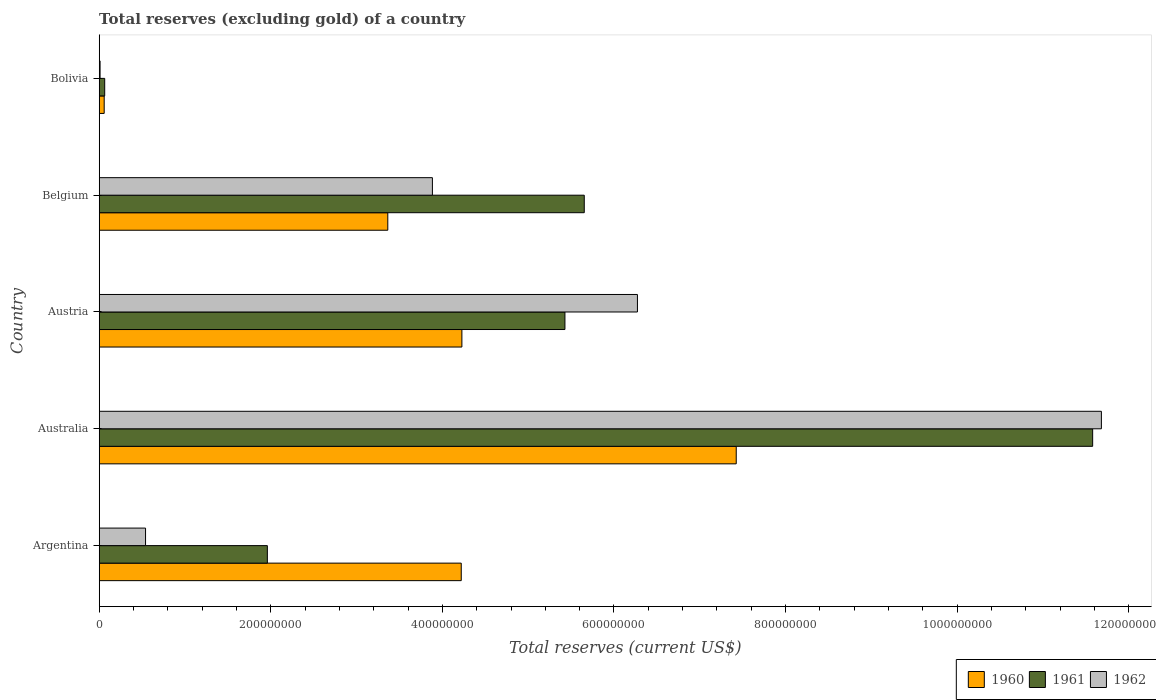How many different coloured bars are there?
Your answer should be very brief. 3. Are the number of bars per tick equal to the number of legend labels?
Make the answer very short. Yes. Are the number of bars on each tick of the Y-axis equal?
Provide a short and direct response. Yes. How many bars are there on the 1st tick from the bottom?
Give a very brief answer. 3. In how many cases, is the number of bars for a given country not equal to the number of legend labels?
Offer a very short reply. 0. What is the total reserves (excluding gold) in 1962 in Belgium?
Ensure brevity in your answer.  3.88e+08. Across all countries, what is the maximum total reserves (excluding gold) in 1961?
Keep it short and to the point. 1.16e+09. Across all countries, what is the minimum total reserves (excluding gold) in 1960?
Give a very brief answer. 5.80e+06. What is the total total reserves (excluding gold) in 1960 in the graph?
Offer a very short reply. 1.93e+09. What is the difference between the total reserves (excluding gold) in 1961 in Australia and that in Bolivia?
Provide a succinct answer. 1.15e+09. What is the difference between the total reserves (excluding gold) in 1962 in Bolivia and the total reserves (excluding gold) in 1960 in Australia?
Your answer should be very brief. -7.42e+08. What is the average total reserves (excluding gold) in 1962 per country?
Make the answer very short. 4.48e+08. What is the difference between the total reserves (excluding gold) in 1962 and total reserves (excluding gold) in 1960 in Argentina?
Provide a short and direct response. -3.68e+08. In how many countries, is the total reserves (excluding gold) in 1960 greater than 880000000 US$?
Provide a succinct answer. 0. What is the ratio of the total reserves (excluding gold) in 1961 in Australia to that in Austria?
Your answer should be very brief. 2.13. What is the difference between the highest and the second highest total reserves (excluding gold) in 1960?
Make the answer very short. 3.20e+08. What is the difference between the highest and the lowest total reserves (excluding gold) in 1960?
Offer a very short reply. 7.37e+08. Is the sum of the total reserves (excluding gold) in 1962 in Australia and Austria greater than the maximum total reserves (excluding gold) in 1960 across all countries?
Offer a terse response. Yes. What does the 1st bar from the bottom in Belgium represents?
Offer a terse response. 1960. Are all the bars in the graph horizontal?
Your response must be concise. Yes. Does the graph contain grids?
Your answer should be compact. No. How many legend labels are there?
Your answer should be compact. 3. What is the title of the graph?
Your answer should be compact. Total reserves (excluding gold) of a country. What is the label or title of the X-axis?
Provide a short and direct response. Total reserves (current US$). What is the Total reserves (current US$) in 1960 in Argentina?
Make the answer very short. 4.22e+08. What is the Total reserves (current US$) in 1961 in Argentina?
Offer a terse response. 1.96e+08. What is the Total reserves (current US$) of 1962 in Argentina?
Provide a succinct answer. 5.40e+07. What is the Total reserves (current US$) in 1960 in Australia?
Provide a short and direct response. 7.43e+08. What is the Total reserves (current US$) of 1961 in Australia?
Your answer should be compact. 1.16e+09. What is the Total reserves (current US$) in 1962 in Australia?
Your answer should be compact. 1.17e+09. What is the Total reserves (current US$) in 1960 in Austria?
Provide a succinct answer. 4.23e+08. What is the Total reserves (current US$) of 1961 in Austria?
Ensure brevity in your answer.  5.43e+08. What is the Total reserves (current US$) of 1962 in Austria?
Your answer should be compact. 6.27e+08. What is the Total reserves (current US$) of 1960 in Belgium?
Offer a very short reply. 3.36e+08. What is the Total reserves (current US$) in 1961 in Belgium?
Provide a short and direct response. 5.65e+08. What is the Total reserves (current US$) in 1962 in Belgium?
Keep it short and to the point. 3.88e+08. What is the Total reserves (current US$) in 1960 in Bolivia?
Provide a short and direct response. 5.80e+06. What is the Total reserves (current US$) of 1961 in Bolivia?
Provide a short and direct response. 6.40e+06. What is the Total reserves (current US$) of 1962 in Bolivia?
Your response must be concise. 1.00e+06. Across all countries, what is the maximum Total reserves (current US$) of 1960?
Your answer should be very brief. 7.43e+08. Across all countries, what is the maximum Total reserves (current US$) of 1961?
Offer a very short reply. 1.16e+09. Across all countries, what is the maximum Total reserves (current US$) of 1962?
Provide a succinct answer. 1.17e+09. Across all countries, what is the minimum Total reserves (current US$) of 1960?
Provide a succinct answer. 5.80e+06. Across all countries, what is the minimum Total reserves (current US$) of 1961?
Make the answer very short. 6.40e+06. What is the total Total reserves (current US$) in 1960 in the graph?
Ensure brevity in your answer.  1.93e+09. What is the total Total reserves (current US$) in 1961 in the graph?
Provide a succinct answer. 2.47e+09. What is the total Total reserves (current US$) of 1962 in the graph?
Ensure brevity in your answer.  2.24e+09. What is the difference between the Total reserves (current US$) in 1960 in Argentina and that in Australia?
Keep it short and to the point. -3.21e+08. What is the difference between the Total reserves (current US$) in 1961 in Argentina and that in Australia?
Ensure brevity in your answer.  -9.62e+08. What is the difference between the Total reserves (current US$) in 1962 in Argentina and that in Australia?
Your response must be concise. -1.11e+09. What is the difference between the Total reserves (current US$) in 1960 in Argentina and that in Austria?
Give a very brief answer. -7.60e+05. What is the difference between the Total reserves (current US$) in 1961 in Argentina and that in Austria?
Your answer should be compact. -3.47e+08. What is the difference between the Total reserves (current US$) of 1962 in Argentina and that in Austria?
Offer a terse response. -5.73e+08. What is the difference between the Total reserves (current US$) of 1960 in Argentina and that in Belgium?
Your answer should be compact. 8.56e+07. What is the difference between the Total reserves (current US$) of 1961 in Argentina and that in Belgium?
Make the answer very short. -3.69e+08. What is the difference between the Total reserves (current US$) of 1962 in Argentina and that in Belgium?
Your answer should be compact. -3.34e+08. What is the difference between the Total reserves (current US$) in 1960 in Argentina and that in Bolivia?
Make the answer very short. 4.16e+08. What is the difference between the Total reserves (current US$) in 1961 in Argentina and that in Bolivia?
Your response must be concise. 1.90e+08. What is the difference between the Total reserves (current US$) in 1962 in Argentina and that in Bolivia?
Make the answer very short. 5.30e+07. What is the difference between the Total reserves (current US$) in 1960 in Australia and that in Austria?
Provide a short and direct response. 3.20e+08. What is the difference between the Total reserves (current US$) in 1961 in Australia and that in Austria?
Provide a short and direct response. 6.15e+08. What is the difference between the Total reserves (current US$) of 1962 in Australia and that in Austria?
Keep it short and to the point. 5.41e+08. What is the difference between the Total reserves (current US$) of 1960 in Australia and that in Belgium?
Offer a terse response. 4.06e+08. What is the difference between the Total reserves (current US$) of 1961 in Australia and that in Belgium?
Ensure brevity in your answer.  5.93e+08. What is the difference between the Total reserves (current US$) of 1962 in Australia and that in Belgium?
Ensure brevity in your answer.  7.80e+08. What is the difference between the Total reserves (current US$) of 1960 in Australia and that in Bolivia?
Your response must be concise. 7.37e+08. What is the difference between the Total reserves (current US$) in 1961 in Australia and that in Bolivia?
Give a very brief answer. 1.15e+09. What is the difference between the Total reserves (current US$) of 1962 in Australia and that in Bolivia?
Ensure brevity in your answer.  1.17e+09. What is the difference between the Total reserves (current US$) of 1960 in Austria and that in Belgium?
Your answer should be very brief. 8.64e+07. What is the difference between the Total reserves (current US$) in 1961 in Austria and that in Belgium?
Your response must be concise. -2.25e+07. What is the difference between the Total reserves (current US$) in 1962 in Austria and that in Belgium?
Offer a terse response. 2.39e+08. What is the difference between the Total reserves (current US$) of 1960 in Austria and that in Bolivia?
Provide a short and direct response. 4.17e+08. What is the difference between the Total reserves (current US$) of 1961 in Austria and that in Bolivia?
Your response must be concise. 5.36e+08. What is the difference between the Total reserves (current US$) in 1962 in Austria and that in Bolivia?
Provide a succinct answer. 6.26e+08. What is the difference between the Total reserves (current US$) in 1960 in Belgium and that in Bolivia?
Offer a terse response. 3.31e+08. What is the difference between the Total reserves (current US$) of 1961 in Belgium and that in Bolivia?
Your answer should be very brief. 5.59e+08. What is the difference between the Total reserves (current US$) of 1962 in Belgium and that in Bolivia?
Provide a succinct answer. 3.87e+08. What is the difference between the Total reserves (current US$) of 1960 in Argentina and the Total reserves (current US$) of 1961 in Australia?
Offer a very short reply. -7.36e+08. What is the difference between the Total reserves (current US$) of 1960 in Argentina and the Total reserves (current US$) of 1962 in Australia?
Your answer should be very brief. -7.46e+08. What is the difference between the Total reserves (current US$) in 1961 in Argentina and the Total reserves (current US$) in 1962 in Australia?
Your answer should be very brief. -9.72e+08. What is the difference between the Total reserves (current US$) in 1960 in Argentina and the Total reserves (current US$) in 1961 in Austria?
Ensure brevity in your answer.  -1.21e+08. What is the difference between the Total reserves (current US$) of 1960 in Argentina and the Total reserves (current US$) of 1962 in Austria?
Offer a terse response. -2.05e+08. What is the difference between the Total reserves (current US$) in 1961 in Argentina and the Total reserves (current US$) in 1962 in Austria?
Give a very brief answer. -4.31e+08. What is the difference between the Total reserves (current US$) in 1960 in Argentina and the Total reserves (current US$) in 1961 in Belgium?
Make the answer very short. -1.43e+08. What is the difference between the Total reserves (current US$) of 1960 in Argentina and the Total reserves (current US$) of 1962 in Belgium?
Give a very brief answer. 3.36e+07. What is the difference between the Total reserves (current US$) of 1961 in Argentina and the Total reserves (current US$) of 1962 in Belgium?
Your answer should be very brief. -1.92e+08. What is the difference between the Total reserves (current US$) of 1960 in Argentina and the Total reserves (current US$) of 1961 in Bolivia?
Your response must be concise. 4.16e+08. What is the difference between the Total reserves (current US$) in 1960 in Argentina and the Total reserves (current US$) in 1962 in Bolivia?
Offer a terse response. 4.21e+08. What is the difference between the Total reserves (current US$) in 1961 in Argentina and the Total reserves (current US$) in 1962 in Bolivia?
Your response must be concise. 1.95e+08. What is the difference between the Total reserves (current US$) in 1960 in Australia and the Total reserves (current US$) in 1961 in Austria?
Give a very brief answer. 2.00e+08. What is the difference between the Total reserves (current US$) in 1960 in Australia and the Total reserves (current US$) in 1962 in Austria?
Your response must be concise. 1.15e+08. What is the difference between the Total reserves (current US$) of 1961 in Australia and the Total reserves (current US$) of 1962 in Austria?
Offer a terse response. 5.31e+08. What is the difference between the Total reserves (current US$) in 1960 in Australia and the Total reserves (current US$) in 1961 in Belgium?
Keep it short and to the point. 1.77e+08. What is the difference between the Total reserves (current US$) of 1960 in Australia and the Total reserves (current US$) of 1962 in Belgium?
Your response must be concise. 3.54e+08. What is the difference between the Total reserves (current US$) in 1961 in Australia and the Total reserves (current US$) in 1962 in Belgium?
Ensure brevity in your answer.  7.70e+08. What is the difference between the Total reserves (current US$) of 1960 in Australia and the Total reserves (current US$) of 1961 in Bolivia?
Your answer should be compact. 7.36e+08. What is the difference between the Total reserves (current US$) of 1960 in Australia and the Total reserves (current US$) of 1962 in Bolivia?
Give a very brief answer. 7.42e+08. What is the difference between the Total reserves (current US$) in 1961 in Australia and the Total reserves (current US$) in 1962 in Bolivia?
Make the answer very short. 1.16e+09. What is the difference between the Total reserves (current US$) of 1960 in Austria and the Total reserves (current US$) of 1961 in Belgium?
Offer a very short reply. -1.43e+08. What is the difference between the Total reserves (current US$) in 1960 in Austria and the Total reserves (current US$) in 1962 in Belgium?
Offer a terse response. 3.44e+07. What is the difference between the Total reserves (current US$) of 1961 in Austria and the Total reserves (current US$) of 1962 in Belgium?
Give a very brief answer. 1.54e+08. What is the difference between the Total reserves (current US$) in 1960 in Austria and the Total reserves (current US$) in 1961 in Bolivia?
Your response must be concise. 4.16e+08. What is the difference between the Total reserves (current US$) in 1960 in Austria and the Total reserves (current US$) in 1962 in Bolivia?
Keep it short and to the point. 4.22e+08. What is the difference between the Total reserves (current US$) in 1961 in Austria and the Total reserves (current US$) in 1962 in Bolivia?
Make the answer very short. 5.42e+08. What is the difference between the Total reserves (current US$) of 1960 in Belgium and the Total reserves (current US$) of 1961 in Bolivia?
Your answer should be very brief. 3.30e+08. What is the difference between the Total reserves (current US$) of 1960 in Belgium and the Total reserves (current US$) of 1962 in Bolivia?
Offer a very short reply. 3.35e+08. What is the difference between the Total reserves (current US$) of 1961 in Belgium and the Total reserves (current US$) of 1962 in Bolivia?
Provide a short and direct response. 5.64e+08. What is the average Total reserves (current US$) in 1960 per country?
Make the answer very short. 3.86e+08. What is the average Total reserves (current US$) of 1961 per country?
Ensure brevity in your answer.  4.94e+08. What is the average Total reserves (current US$) of 1962 per country?
Offer a very short reply. 4.48e+08. What is the difference between the Total reserves (current US$) in 1960 and Total reserves (current US$) in 1961 in Argentina?
Ensure brevity in your answer.  2.26e+08. What is the difference between the Total reserves (current US$) of 1960 and Total reserves (current US$) of 1962 in Argentina?
Your response must be concise. 3.68e+08. What is the difference between the Total reserves (current US$) of 1961 and Total reserves (current US$) of 1962 in Argentina?
Provide a succinct answer. 1.42e+08. What is the difference between the Total reserves (current US$) of 1960 and Total reserves (current US$) of 1961 in Australia?
Offer a terse response. -4.15e+08. What is the difference between the Total reserves (current US$) in 1960 and Total reserves (current US$) in 1962 in Australia?
Ensure brevity in your answer.  -4.26e+08. What is the difference between the Total reserves (current US$) in 1961 and Total reserves (current US$) in 1962 in Australia?
Provide a succinct answer. -1.02e+07. What is the difference between the Total reserves (current US$) of 1960 and Total reserves (current US$) of 1961 in Austria?
Offer a terse response. -1.20e+08. What is the difference between the Total reserves (current US$) of 1960 and Total reserves (current US$) of 1962 in Austria?
Offer a terse response. -2.05e+08. What is the difference between the Total reserves (current US$) in 1961 and Total reserves (current US$) in 1962 in Austria?
Offer a very short reply. -8.45e+07. What is the difference between the Total reserves (current US$) in 1960 and Total reserves (current US$) in 1961 in Belgium?
Provide a succinct answer. -2.29e+08. What is the difference between the Total reserves (current US$) in 1960 and Total reserves (current US$) in 1962 in Belgium?
Make the answer very short. -5.20e+07. What is the difference between the Total reserves (current US$) in 1961 and Total reserves (current US$) in 1962 in Belgium?
Provide a short and direct response. 1.77e+08. What is the difference between the Total reserves (current US$) of 1960 and Total reserves (current US$) of 1961 in Bolivia?
Make the answer very short. -6.00e+05. What is the difference between the Total reserves (current US$) of 1960 and Total reserves (current US$) of 1962 in Bolivia?
Your answer should be compact. 4.80e+06. What is the difference between the Total reserves (current US$) of 1961 and Total reserves (current US$) of 1962 in Bolivia?
Keep it short and to the point. 5.40e+06. What is the ratio of the Total reserves (current US$) of 1960 in Argentina to that in Australia?
Keep it short and to the point. 0.57. What is the ratio of the Total reserves (current US$) of 1961 in Argentina to that in Australia?
Give a very brief answer. 0.17. What is the ratio of the Total reserves (current US$) in 1962 in Argentina to that in Australia?
Provide a short and direct response. 0.05. What is the ratio of the Total reserves (current US$) of 1960 in Argentina to that in Austria?
Your response must be concise. 1. What is the ratio of the Total reserves (current US$) of 1961 in Argentina to that in Austria?
Offer a terse response. 0.36. What is the ratio of the Total reserves (current US$) of 1962 in Argentina to that in Austria?
Offer a very short reply. 0.09. What is the ratio of the Total reserves (current US$) of 1960 in Argentina to that in Belgium?
Your response must be concise. 1.25. What is the ratio of the Total reserves (current US$) in 1961 in Argentina to that in Belgium?
Make the answer very short. 0.35. What is the ratio of the Total reserves (current US$) of 1962 in Argentina to that in Belgium?
Make the answer very short. 0.14. What is the ratio of the Total reserves (current US$) of 1960 in Argentina to that in Bolivia?
Make the answer very short. 72.76. What is the ratio of the Total reserves (current US$) of 1961 in Argentina to that in Bolivia?
Ensure brevity in your answer.  30.62. What is the ratio of the Total reserves (current US$) in 1960 in Australia to that in Austria?
Offer a very short reply. 1.76. What is the ratio of the Total reserves (current US$) of 1961 in Australia to that in Austria?
Offer a very short reply. 2.13. What is the ratio of the Total reserves (current US$) of 1962 in Australia to that in Austria?
Your answer should be compact. 1.86. What is the ratio of the Total reserves (current US$) in 1960 in Australia to that in Belgium?
Give a very brief answer. 2.21. What is the ratio of the Total reserves (current US$) of 1961 in Australia to that in Belgium?
Offer a terse response. 2.05. What is the ratio of the Total reserves (current US$) of 1962 in Australia to that in Belgium?
Provide a short and direct response. 3.01. What is the ratio of the Total reserves (current US$) in 1960 in Australia to that in Bolivia?
Ensure brevity in your answer.  128.03. What is the ratio of the Total reserves (current US$) of 1961 in Australia to that in Bolivia?
Offer a very short reply. 180.94. What is the ratio of the Total reserves (current US$) of 1962 in Australia to that in Bolivia?
Keep it short and to the point. 1168.18. What is the ratio of the Total reserves (current US$) of 1960 in Austria to that in Belgium?
Your answer should be compact. 1.26. What is the ratio of the Total reserves (current US$) of 1961 in Austria to that in Belgium?
Your answer should be compact. 0.96. What is the ratio of the Total reserves (current US$) of 1962 in Austria to that in Belgium?
Make the answer very short. 1.62. What is the ratio of the Total reserves (current US$) of 1960 in Austria to that in Bolivia?
Give a very brief answer. 72.89. What is the ratio of the Total reserves (current US$) in 1961 in Austria to that in Bolivia?
Keep it short and to the point. 84.82. What is the ratio of the Total reserves (current US$) in 1962 in Austria to that in Bolivia?
Offer a very short reply. 627.38. What is the ratio of the Total reserves (current US$) in 1960 in Belgium to that in Bolivia?
Keep it short and to the point. 58. What is the ratio of the Total reserves (current US$) of 1961 in Belgium to that in Bolivia?
Your response must be concise. 88.34. What is the ratio of the Total reserves (current US$) of 1962 in Belgium to that in Bolivia?
Provide a succinct answer. 388.39. What is the difference between the highest and the second highest Total reserves (current US$) of 1960?
Your answer should be compact. 3.20e+08. What is the difference between the highest and the second highest Total reserves (current US$) in 1961?
Your response must be concise. 5.93e+08. What is the difference between the highest and the second highest Total reserves (current US$) of 1962?
Your response must be concise. 5.41e+08. What is the difference between the highest and the lowest Total reserves (current US$) in 1960?
Your answer should be very brief. 7.37e+08. What is the difference between the highest and the lowest Total reserves (current US$) of 1961?
Provide a succinct answer. 1.15e+09. What is the difference between the highest and the lowest Total reserves (current US$) in 1962?
Provide a short and direct response. 1.17e+09. 